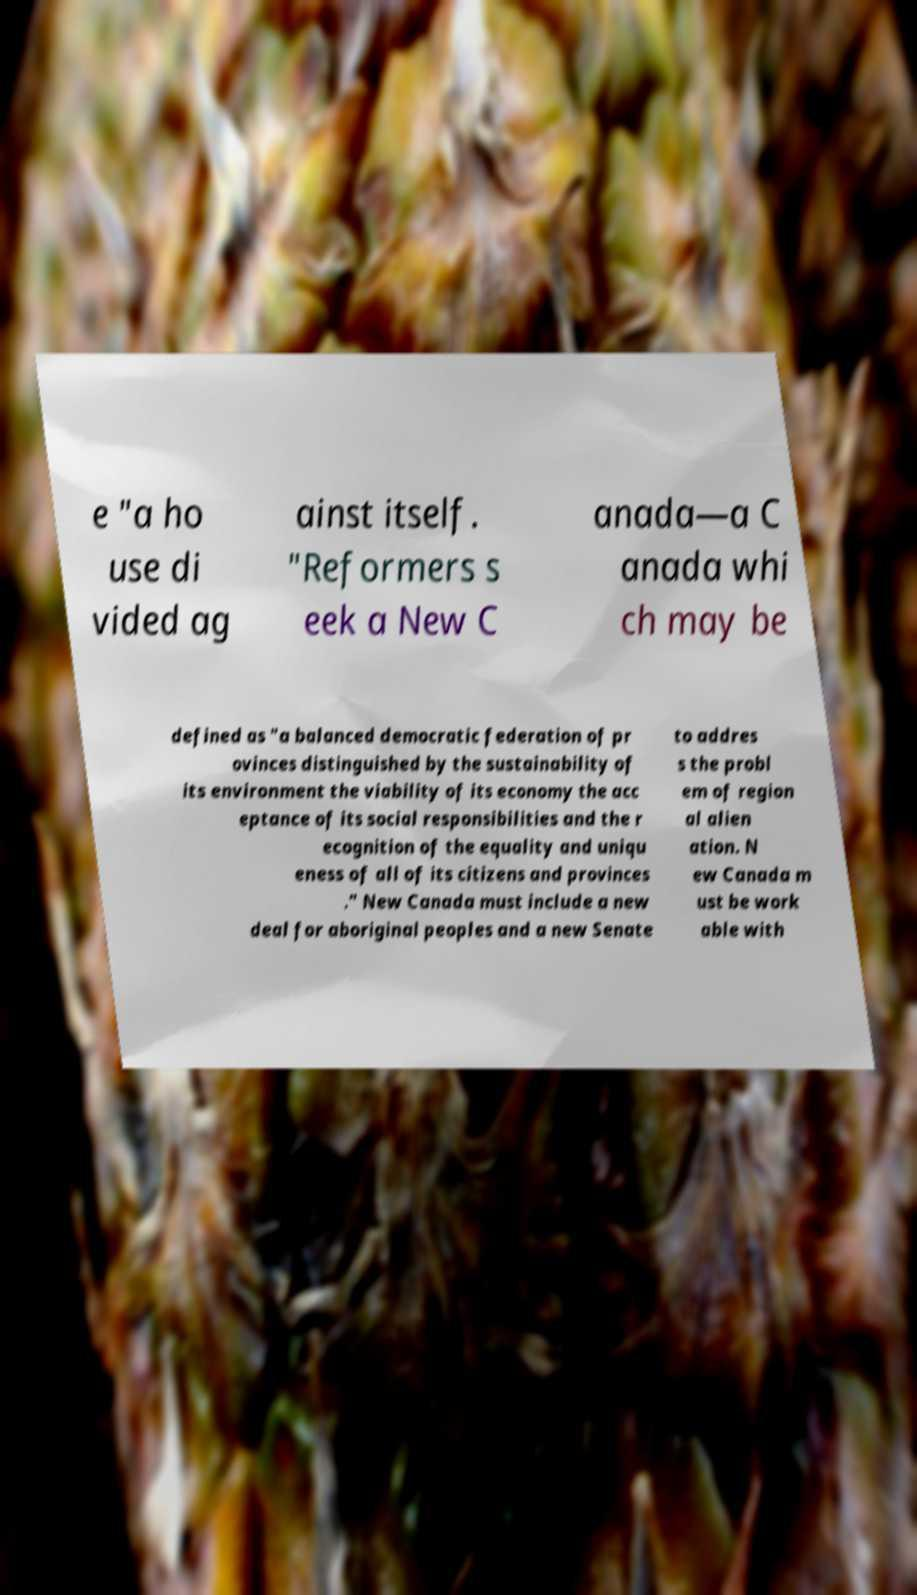Could you extract and type out the text from this image? e "a ho use di vided ag ainst itself. "Reformers s eek a New C anada—a C anada whi ch may be defined as "a balanced democratic federation of pr ovinces distinguished by the sustainability of its environment the viability of its economy the acc eptance of its social responsibilities and the r ecognition of the equality and uniqu eness of all of its citizens and provinces ." New Canada must include a new deal for aboriginal peoples and a new Senate to addres s the probl em of region al alien ation. N ew Canada m ust be work able with 